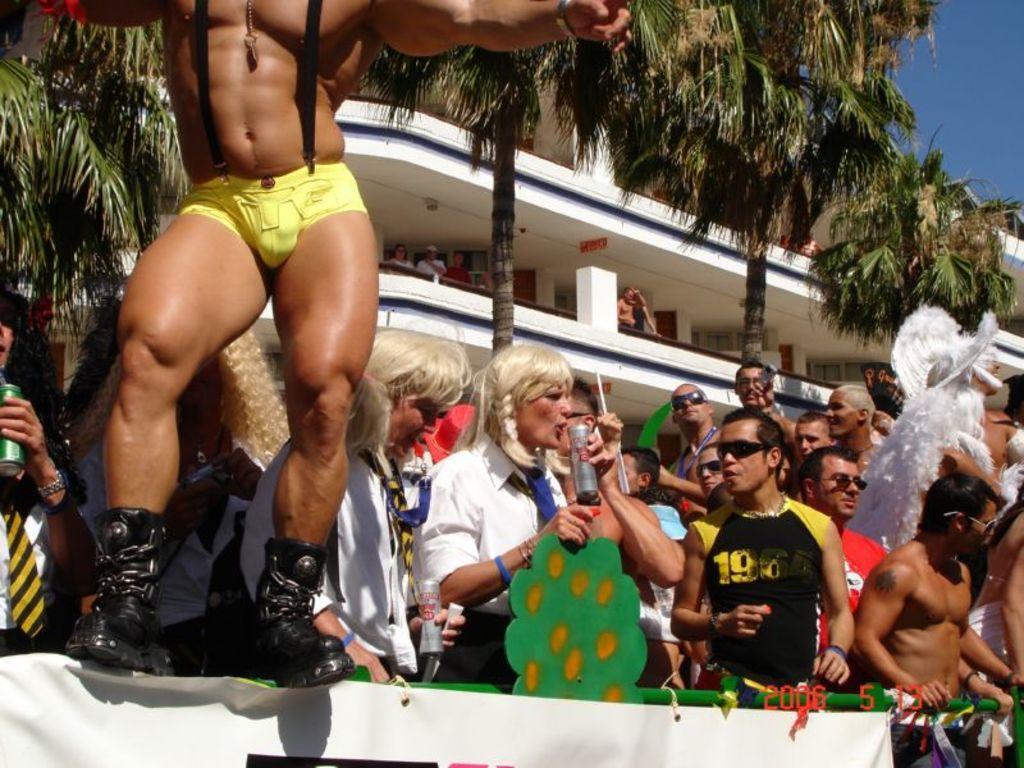In one or two sentences, can you explain what this image depicts? In this image there are people standing in front of the metal fence. In front of the image there is a banner. In the background of the image there are trees, buildings and sky. 